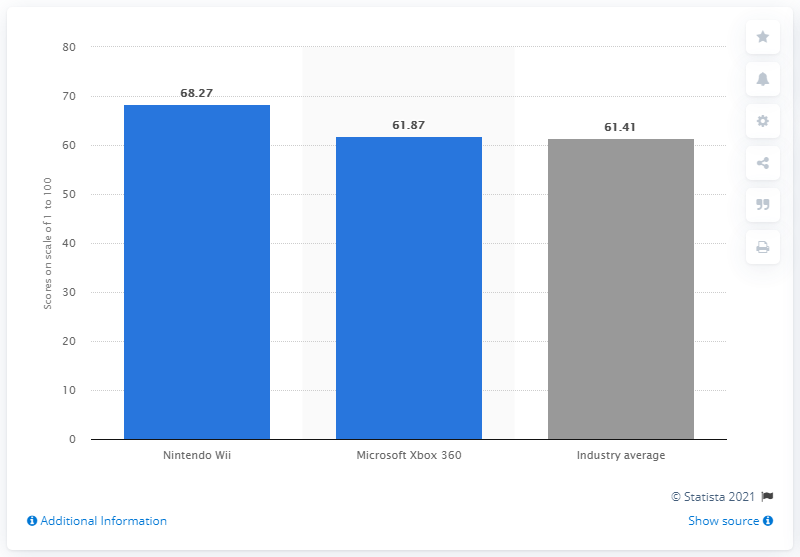What was Nintendo's equity score in 2012? In 2012, Nintendo's equity score was 68.27, as depicted in the graph. This score represents a competitive figure within the gaming industry, slightly above the industry average of 61.41 and ahead of Microsoft Xbox 360, which scored 61.87. 